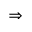Convert formula to latex. <formula><loc_0><loc_0><loc_500><loc_500>\Rightarrow</formula> 